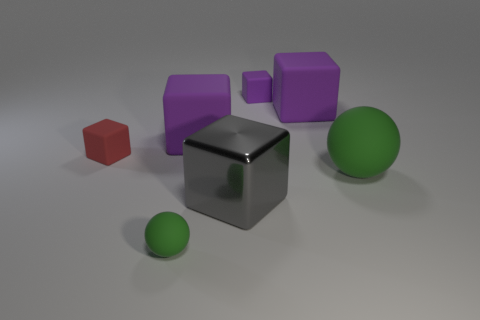There is a small object in front of the matte sphere that is on the right side of the metal cube; is there a purple object right of it?
Your answer should be compact. Yes. What is the size of the gray metal cube?
Make the answer very short. Large. What is the size of the green thing that is behind the metallic object?
Your answer should be compact. Large. There is a cube that is in front of the red thing; does it have the same size as the small green matte object?
Your response must be concise. No. Is there any other thing of the same color as the big ball?
Keep it short and to the point. Yes. The big metal thing is what shape?
Offer a very short reply. Cube. How many things are to the left of the small purple matte object and on the right side of the red block?
Ensure brevity in your answer.  3. Do the small sphere and the big sphere have the same color?
Provide a short and direct response. Yes. There is a gray object that is the same shape as the red object; what is its material?
Ensure brevity in your answer.  Metal. Is there anything else that has the same material as the gray block?
Your answer should be compact. No. 